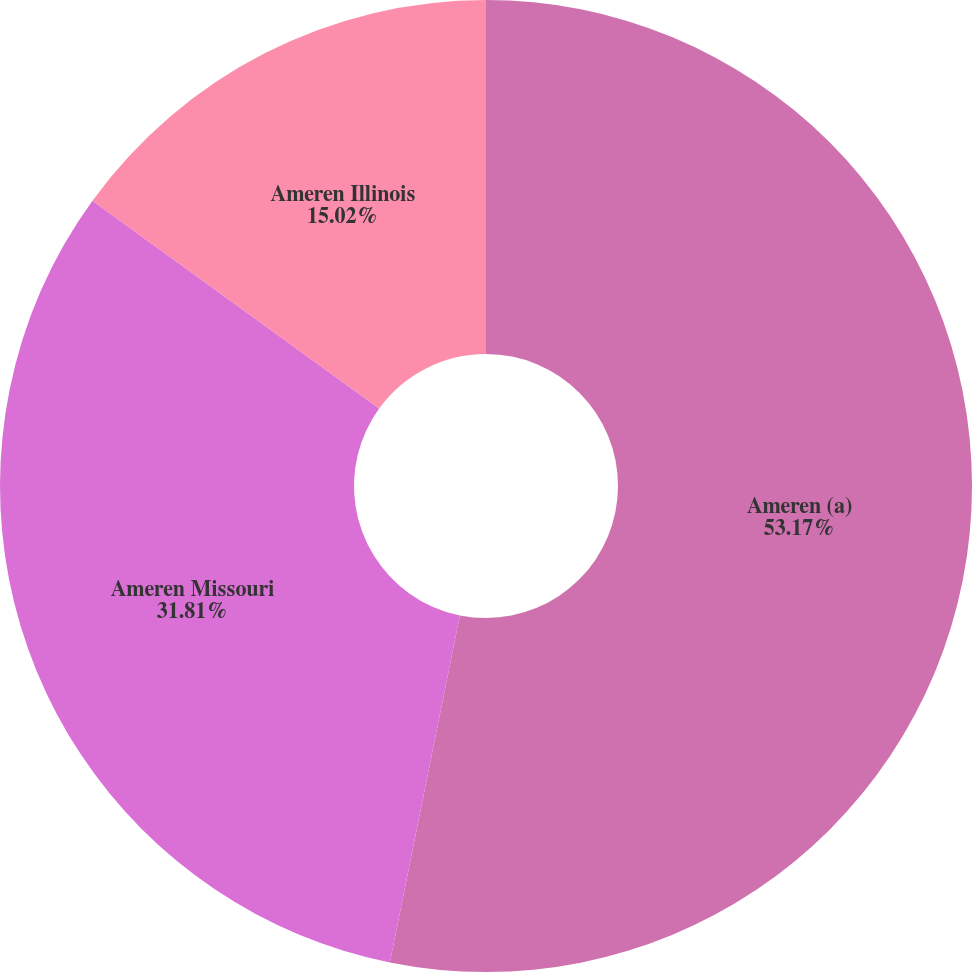<chart> <loc_0><loc_0><loc_500><loc_500><pie_chart><fcel>Ameren (a)<fcel>Ameren Missouri<fcel>Ameren Illinois<nl><fcel>53.17%<fcel>31.81%<fcel>15.02%<nl></chart> 